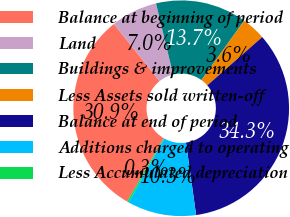<chart> <loc_0><loc_0><loc_500><loc_500><pie_chart><fcel>Balance at beginning of period<fcel>Land<fcel>Buildings & improvements<fcel>Less Assets sold written-off<fcel>Balance at end of period<fcel>Additions charged to operating<fcel>Less Accumulated depreciation<nl><fcel>30.91%<fcel>6.97%<fcel>13.67%<fcel>3.61%<fcel>34.26%<fcel>10.32%<fcel>0.26%<nl></chart> 